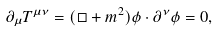<formula> <loc_0><loc_0><loc_500><loc_500>\partial _ { \mu } T ^ { \mu \nu } = ( \square + m ^ { 2 } ) \phi \cdot \partial ^ { \nu } \phi = 0 ,</formula> 